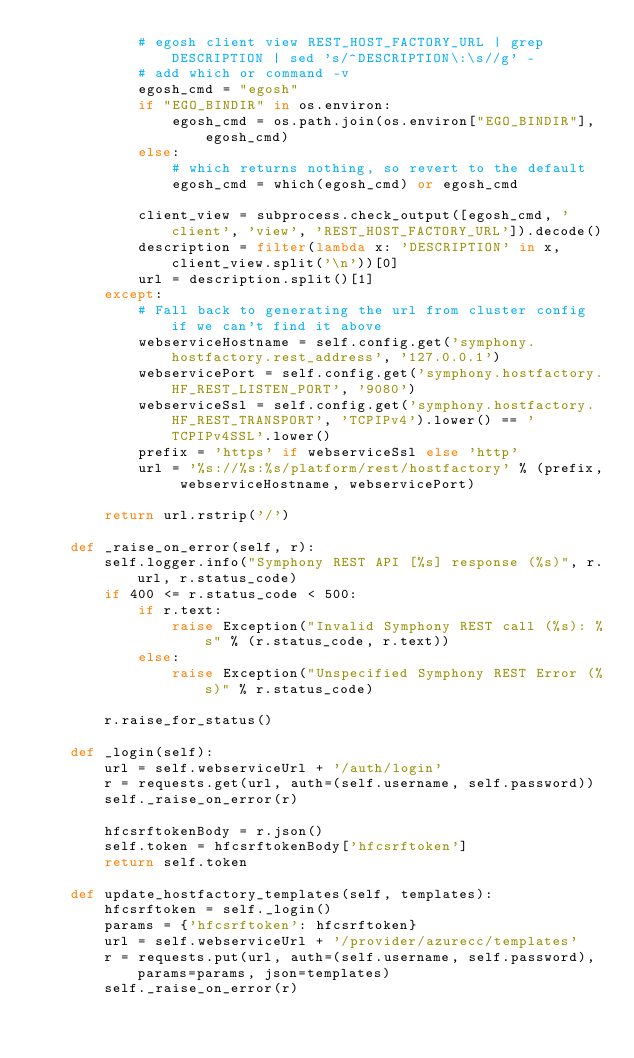<code> <loc_0><loc_0><loc_500><loc_500><_Python_>            # egosh client view REST_HOST_FACTORY_URL | grep DESCRIPTION | sed 's/^DESCRIPTION\:\s//g' -
            # add which or command -v
            egosh_cmd = "egosh"
            if "EGO_BINDIR" in os.environ:
                egosh_cmd = os.path.join(os.environ["EGO_BINDIR"], egosh_cmd)
            else:
                # which returns nothing, so revert to the default
                egosh_cmd = which(egosh_cmd) or egosh_cmd

            client_view = subprocess.check_output([egosh_cmd, 'client', 'view', 'REST_HOST_FACTORY_URL']).decode()
            description = filter(lambda x: 'DESCRIPTION' in x, client_view.split('\n'))[0]        
            url = description.split()[1]
        except:
            # Fall back to generating the url from cluster config if we can't find it above
            webserviceHostname = self.config.get('symphony.hostfactory.rest_address', '127.0.0.1')
            webservicePort = self.config.get('symphony.hostfactory.HF_REST_LISTEN_PORT', '9080')
            webserviceSsl = self.config.get('symphony.hostfactory.HF_REST_TRANSPORT', 'TCPIPv4').lower() == 'TCPIPv4SSL'.lower()
            prefix = 'https' if webserviceSsl else 'http'
            url = '%s://%s:%s/platform/rest/hostfactory' % (prefix, webserviceHostname, webservicePort)

        return url.rstrip('/')

    def _raise_on_error(self, r):
        self.logger.info("Symphony REST API [%s] response (%s)", r.url, r.status_code)
        if 400 <= r.status_code < 500:
            if r.text:
                raise Exception("Invalid Symphony REST call (%s): %s" % (r.status_code, r.text))
            else:
                raise Exception("Unspecified Symphony REST Error (%s)" % r.status_code)

        r.raise_for_status()        
    
    def _login(self):
        url = self.webserviceUrl + '/auth/login'
        r = requests.get(url, auth=(self.username, self.password))
        self._raise_on_error(r)
        
        hfcsrftokenBody = r.json()
        self.token = hfcsrftokenBody['hfcsrftoken']
        return self.token

    def update_hostfactory_templates(self, templates):
        hfcsrftoken = self._login()
        params = {'hfcsrftoken': hfcsrftoken}
        url = self.webserviceUrl + '/provider/azurecc/templates'
        r = requests.put(url, auth=(self.username, self.password), params=params, json=templates)
        self._raise_on_error(r)
</code> 